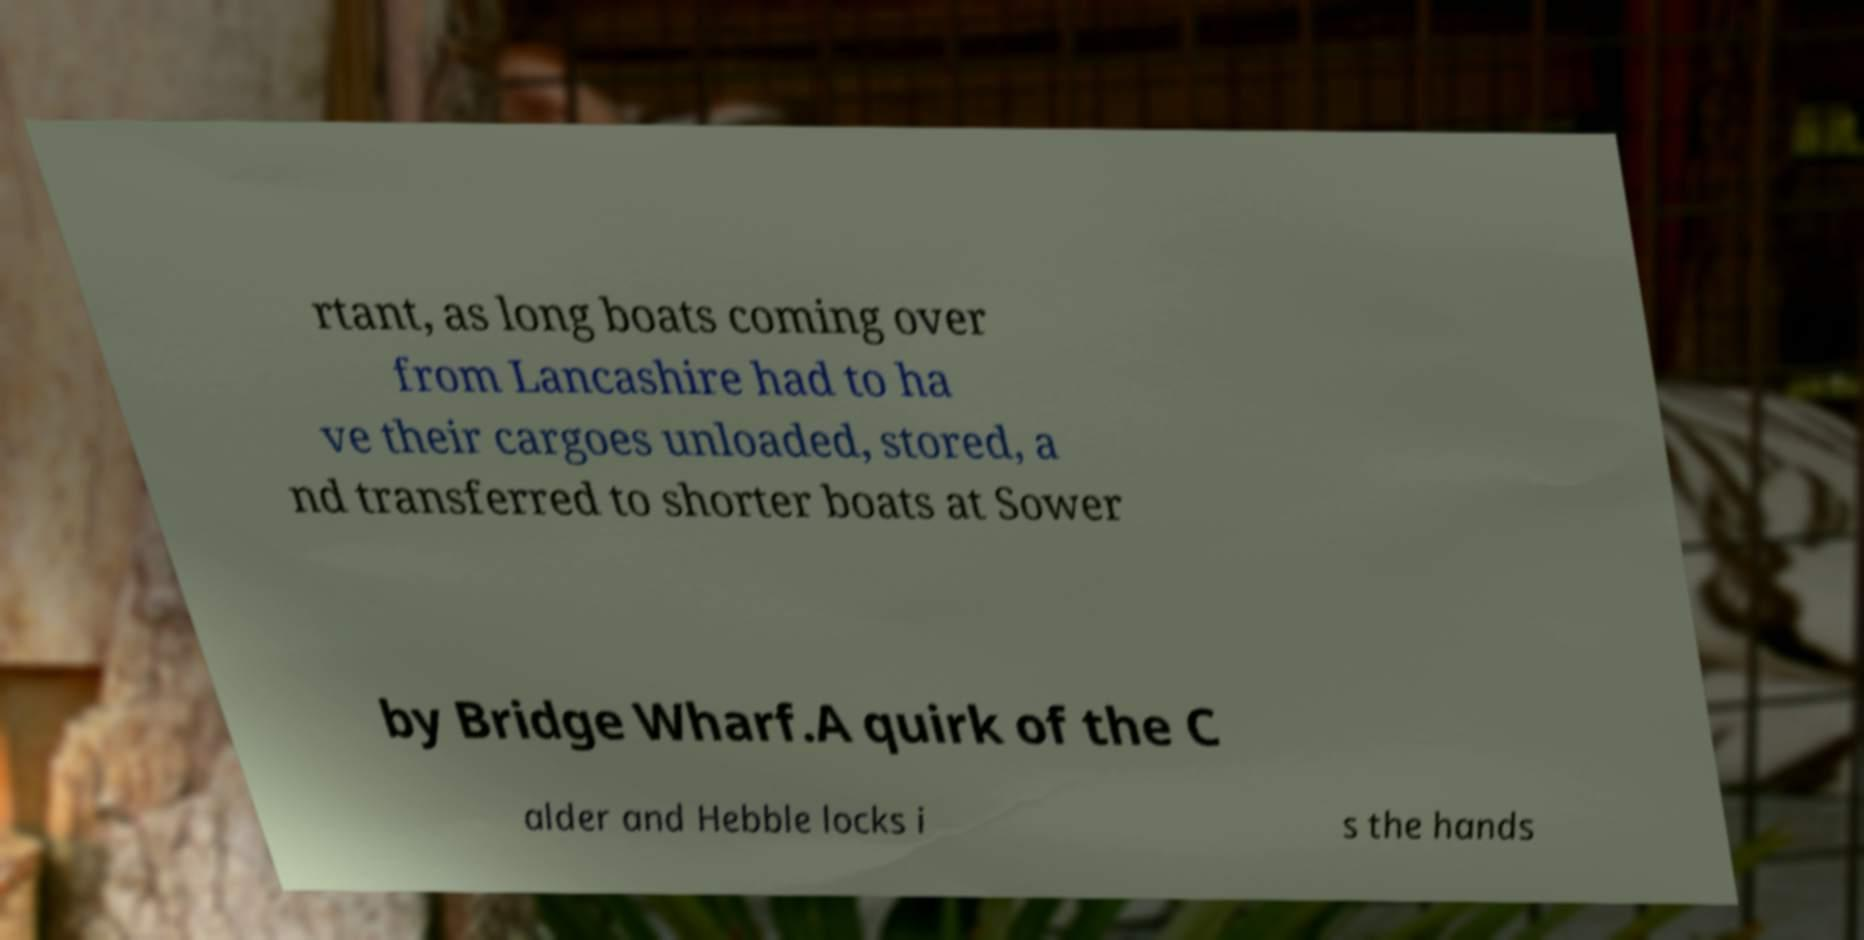There's text embedded in this image that I need extracted. Can you transcribe it verbatim? rtant, as long boats coming over from Lancashire had to ha ve their cargoes unloaded, stored, a nd transferred to shorter boats at Sower by Bridge Wharf.A quirk of the C alder and Hebble locks i s the hands 